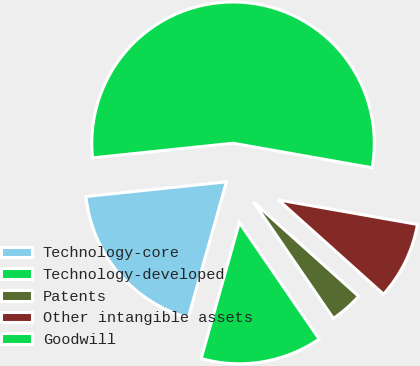<chart> <loc_0><loc_0><loc_500><loc_500><pie_chart><fcel>Technology-core<fcel>Technology-developed<fcel>Patents<fcel>Other intangible assets<fcel>Goodwill<nl><fcel>18.99%<fcel>13.92%<fcel>3.8%<fcel>8.86%<fcel>54.43%<nl></chart> 